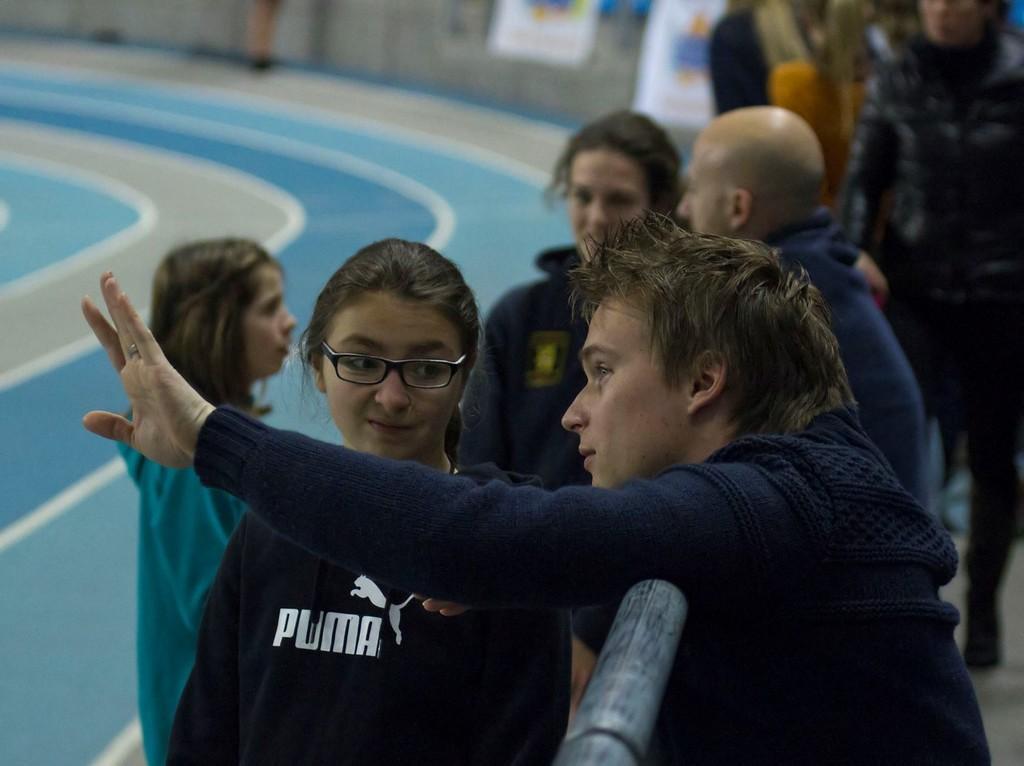In one or two sentences, can you explain what this image depicts? This image consists of many people standing. They are wearing blue color dress. In the front, the girl is wearing specs. On the left, there is a ground. The background is blurred. 